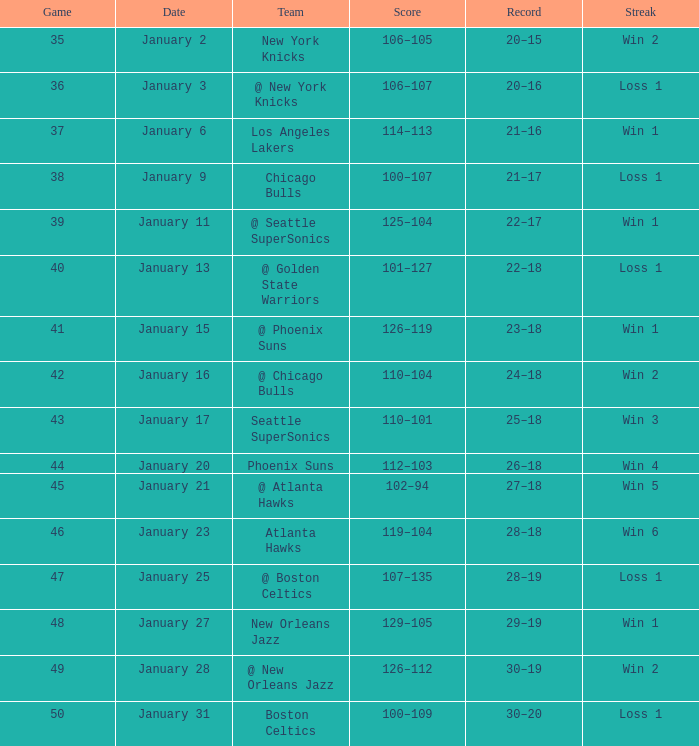With a 20-16 record in the game, what is the streak? Loss 1. 